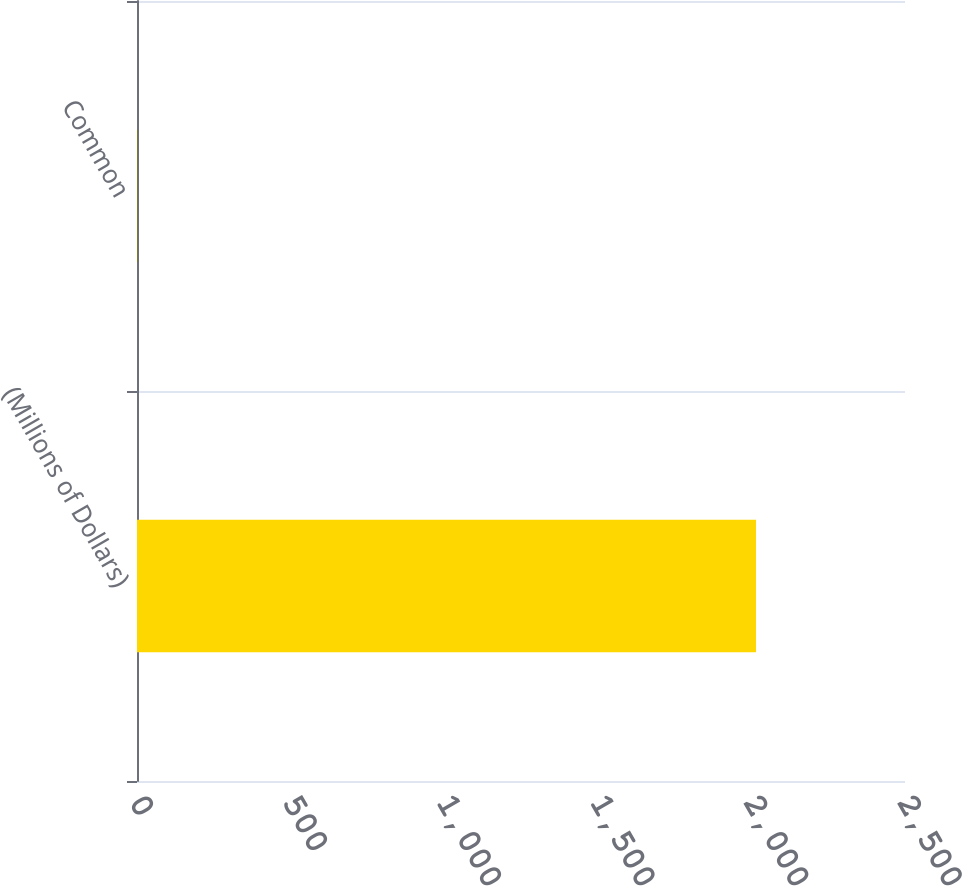<chart> <loc_0><loc_0><loc_500><loc_500><bar_chart><fcel>(Millions of Dollars)<fcel>Common<nl><fcel>2015<fcel>2<nl></chart> 